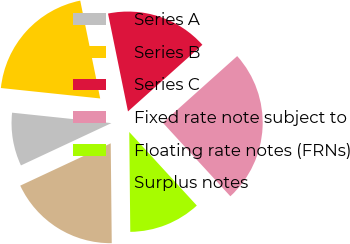Convert chart to OTSL. <chart><loc_0><loc_0><loc_500><loc_500><pie_chart><fcel>Series A<fcel>Series B<fcel>Series C<fcel>Fixed rate note subject to<fcel>Floating rate notes (FRNs)<fcel>Surplus notes<nl><fcel>8.63%<fcel>20.13%<fcel>16.58%<fcel>24.8%<fcel>11.66%<fcel>18.2%<nl></chart> 